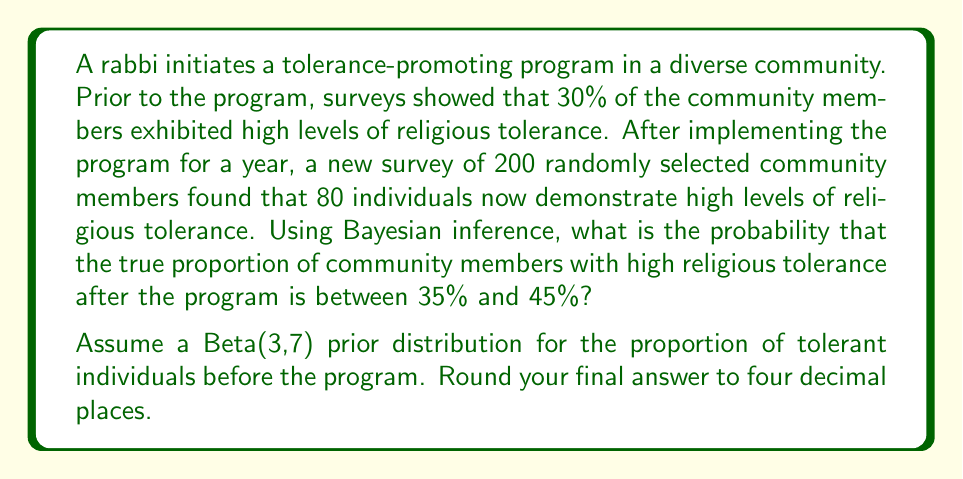Can you answer this question? Let's approach this step-by-step using Bayesian inference:

1) We start with a Beta(3,7) prior distribution for the proportion of tolerant individuals (θ).

2) Our data shows 80 successes out of 200 trials.

3) The posterior distribution is Beta(α + successes, β + failures), where α and β are the parameters of the prior distribution.
   
   Posterior: Beta(3 + 80, 7 + 120) = Beta(83, 127)

4) To find the probability that θ is between 35% and 45%, we need to integrate the posterior distribution between these values:

   $$P(0.35 < θ < 0.45) = \int_{0.35}^{0.45} \frac{θ^{82}(1-θ)^{126}}{B(83,127)} dθ$$

   where B(83,127) is the beta function.

5) This integral doesn't have a closed-form solution, so we need to use numerical methods or the cumulative distribution function (CDF) of the Beta distribution.

6) Using the CDF of the Beta(83,127) distribution:

   $$P(0.35 < θ < 0.45) = CDF_{Beta(83,127)}(0.45) - CDF_{Beta(83,127)}(0.35)$$

7) Calculating this (using statistical software or a calculator with Beta distribution functions):

   $$CDF_{Beta(83,127)}(0.45) ≈ 0.9927$$
   $$CDF_{Beta(83,127)}(0.35) ≈ 0.0780$$

8) Therefore:

   $$P(0.35 < θ < 0.45) ≈ 0.9927 - 0.0780 = 0.9147$$

9) Rounding to four decimal places: 0.9147
Answer: 0.9147 